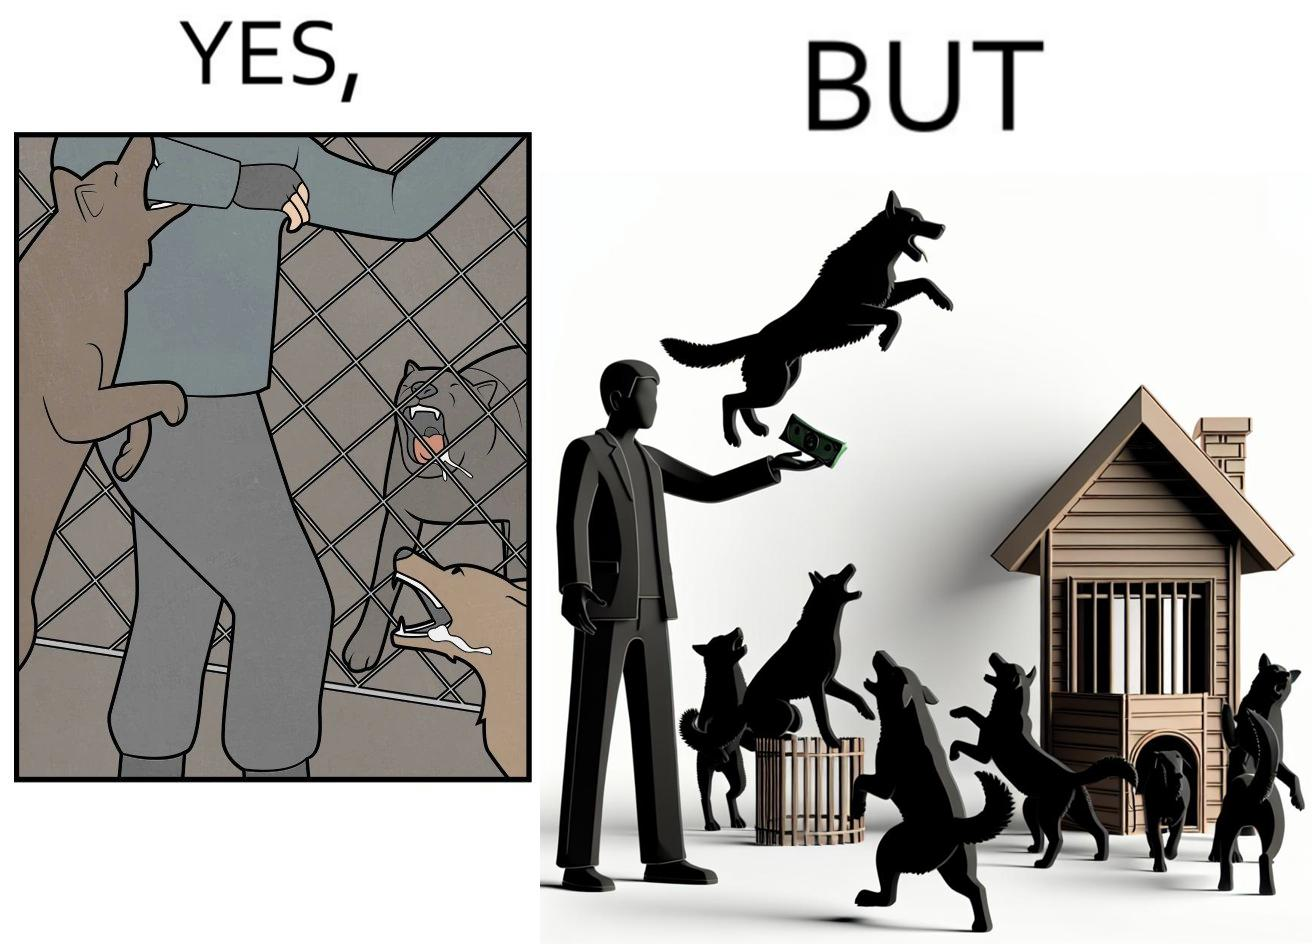Explain the humor or irony in this image. The images are ironic since they show how dogs choose to attack a well wisher making a donation for helping dogs. It is sad that dogs mistake a well wisher and bite him while he is trying to help them. 